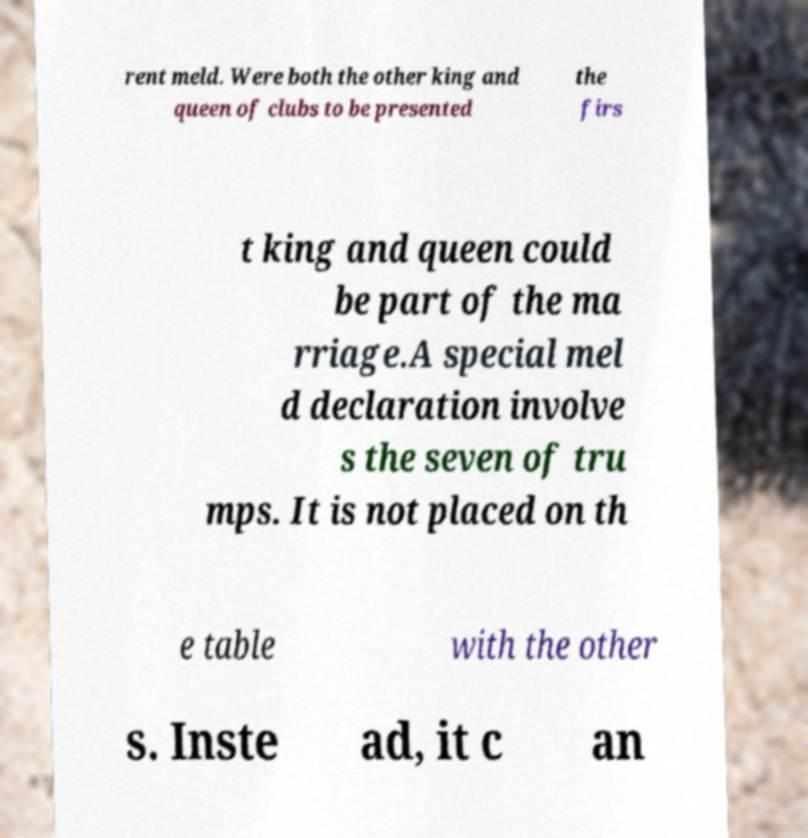Could you extract and type out the text from this image? rent meld. Were both the other king and queen of clubs to be presented the firs t king and queen could be part of the ma rriage.A special mel d declaration involve s the seven of tru mps. It is not placed on th e table with the other s. Inste ad, it c an 